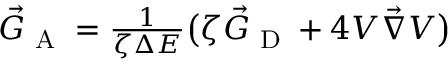<formula> <loc_0><loc_0><loc_500><loc_500>\begin{array} { r } { \vec { G } _ { A } = \frac { 1 } { \zeta \Delta E } \left ( \zeta \vec { G } _ { D } + 4 V \vec { \nabla } V \right ) } \end{array}</formula> 